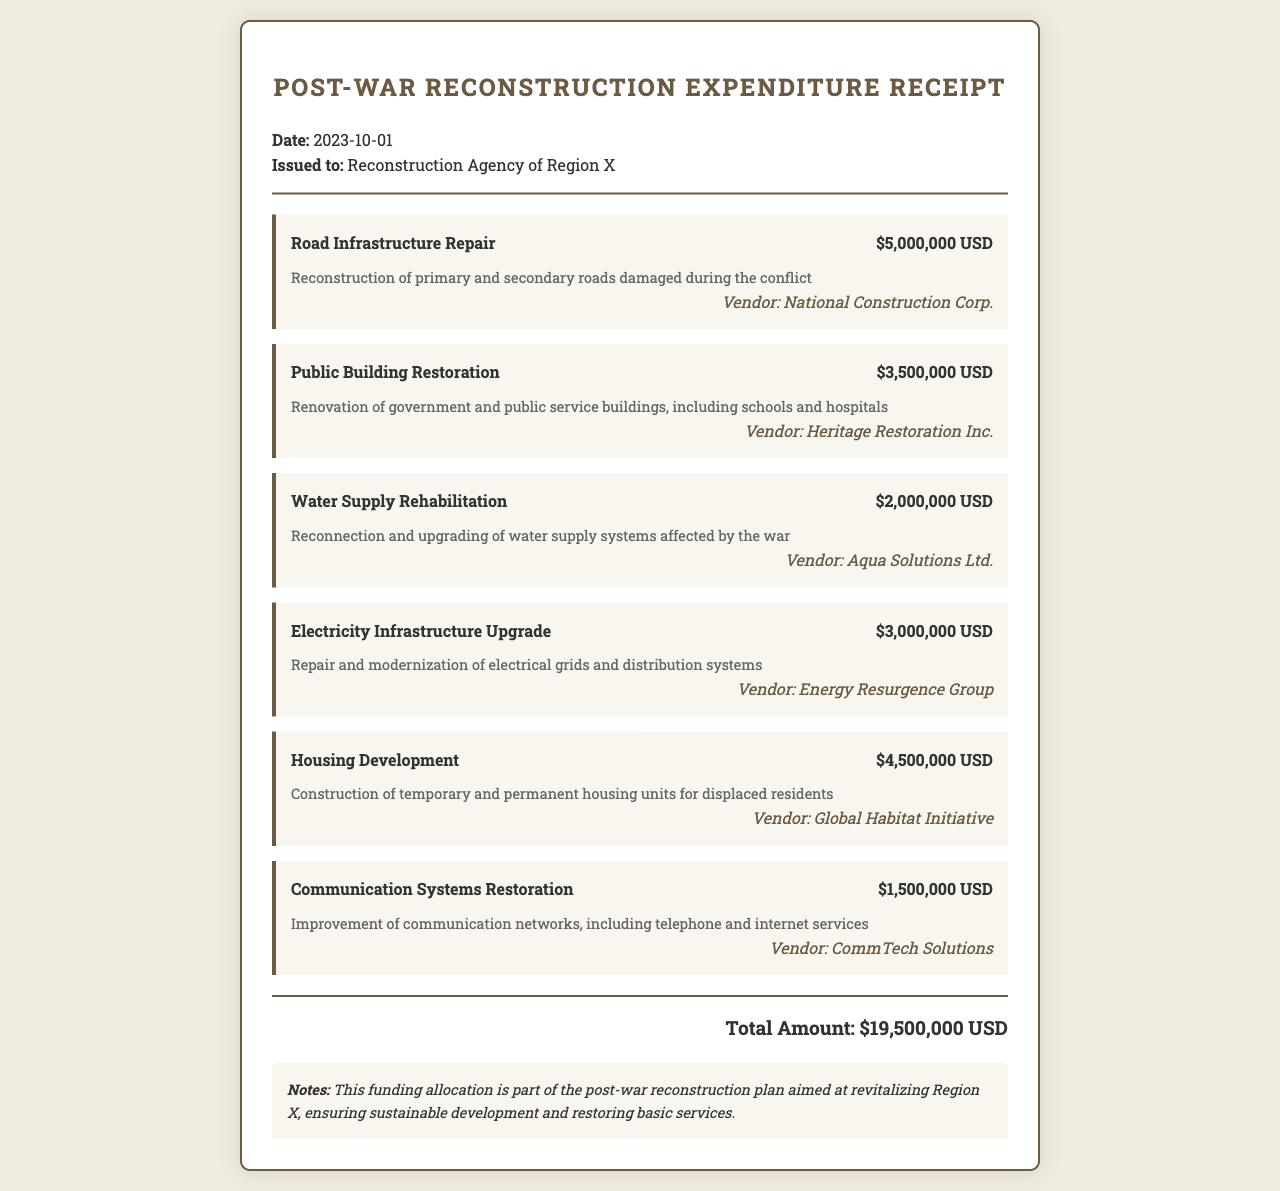What is the date of the receipt? The date of the receipt is explicitly stated in the header section of the document.
Answer: 2023-10-01 Who is the receipt issued to? The receipt mentions the name of the issuing agency, which is included in the header.
Answer: Reconstruction Agency of Region X What is the total amount allocated for reconstruction? The total amount is clearly indicated at the bottom of the document.
Answer: $19,500,000 USD How much was allocated for Road Infrastructure Repair? The amount for each allocation is listed under the respective item in the document.
Answer: $5,000,000 USD Which vendor is responsible for Public Building Restoration? The vendor's name is provided beneath the respective allocation item.
Answer: Heritage Restoration Inc What is the purpose of the Water Supply Rehabilitation? The purpose is described in the description section of the corresponding allocation.
Answer: Reconnection and upgrading of water supply systems How much is allocated for Housing Development? The amount is detailed in the item header for Housing Development.
Answer: $4,500,000 USD What is one of the notes in the document? The notes section contains information about the funding allocation's purpose.
Answer: Part of the post-war reconstruction plan Which item has the lowest funding allocation? Comparing the funding amounts across all items reveals which one has the least.
Answer: Communication Systems Restoration 